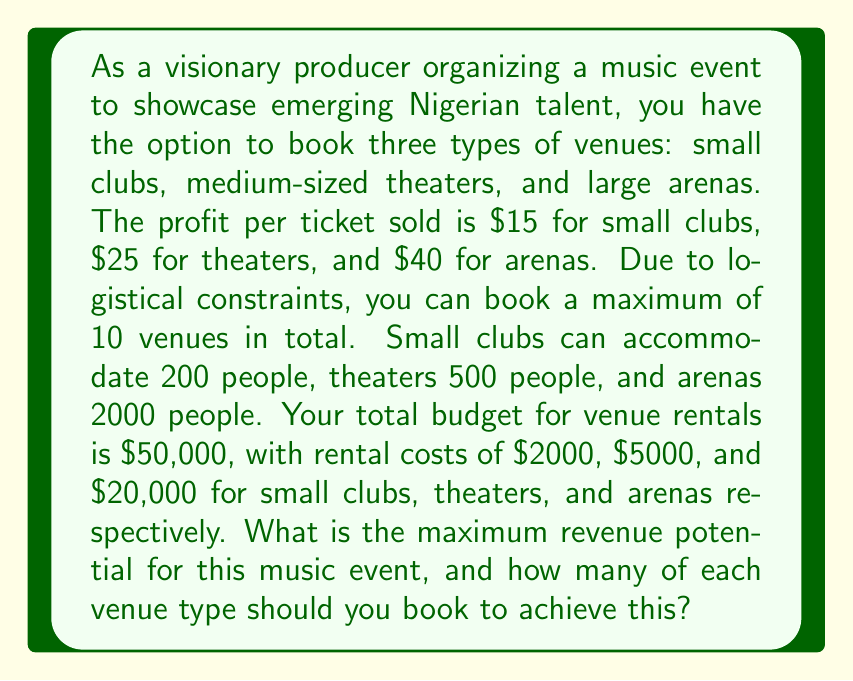Help me with this question. Let's approach this problem using linear programming:

1. Define variables:
   Let $x$ = number of small clubs
   Let $y$ = number of medium theaters
   Let $z$ = number of large arenas

2. Objective function (maximize revenue):
   $$\text{Revenue} = 200 \cdot 15x + 500 \cdot 25y + 2000 \cdot 40z = 3000x + 12500y + 80000z$$

3. Constraints:
   a) Total number of venues: $x + y + z \leq 10$
   b) Budget constraint: $2000x + 5000y + 20000z \leq 50000$
   c) Non-negativity: $x, y, z \geq 0$ and integers

4. Set up the linear programming problem:
   Maximize: $3000x + 12500y + 80000z$
   Subject to:
   $$\begin{align}
   x + y + z &\leq 10 \\
   2000x + 5000y + 20000z &\leq 50000 \\
   x, y, z &\geq 0 \text{ and integers}
   \end{align}$$

5. Solve using the simplex method or linear programming software:
   The optimal solution is:
   $x = 5$ (small clubs)
   $y = 4$ (medium theaters)
   $z = 1$ (large arena)

6. Calculate the maximum revenue:
   $$\text{Revenue} = 3000(5) + 12500(4) + 80000(1) = 15000 + 50000 + 80000 = 145000$$

Therefore, the maximum revenue potential is $145,000, achieved by booking 5 small clubs, 4 medium theaters, and 1 large arena.
Answer: $145,000; 5 small clubs, 4 medium theaters, 1 large arena 